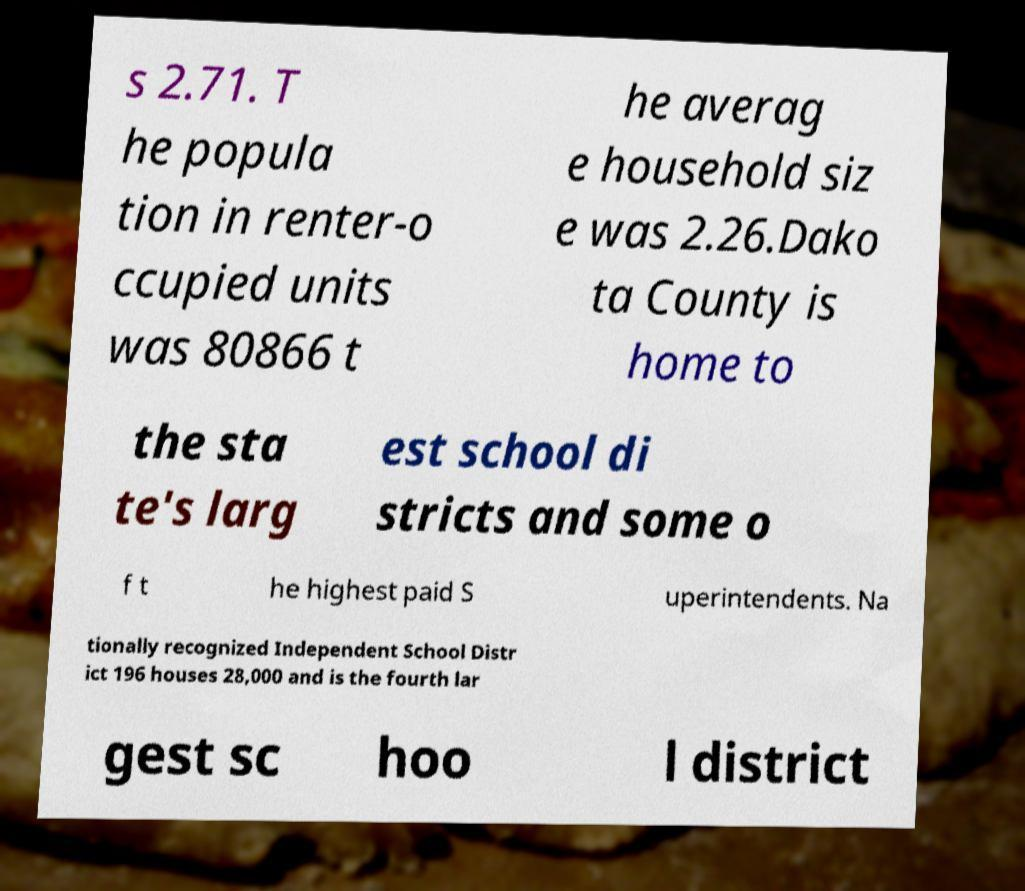Can you read and provide the text displayed in the image?This photo seems to have some interesting text. Can you extract and type it out for me? s 2.71. T he popula tion in renter-o ccupied units was 80866 t he averag e household siz e was 2.26.Dako ta County is home to the sta te's larg est school di stricts and some o f t he highest paid S uperintendents. Na tionally recognized Independent School Distr ict 196 houses 28,000 and is the fourth lar gest sc hoo l district 